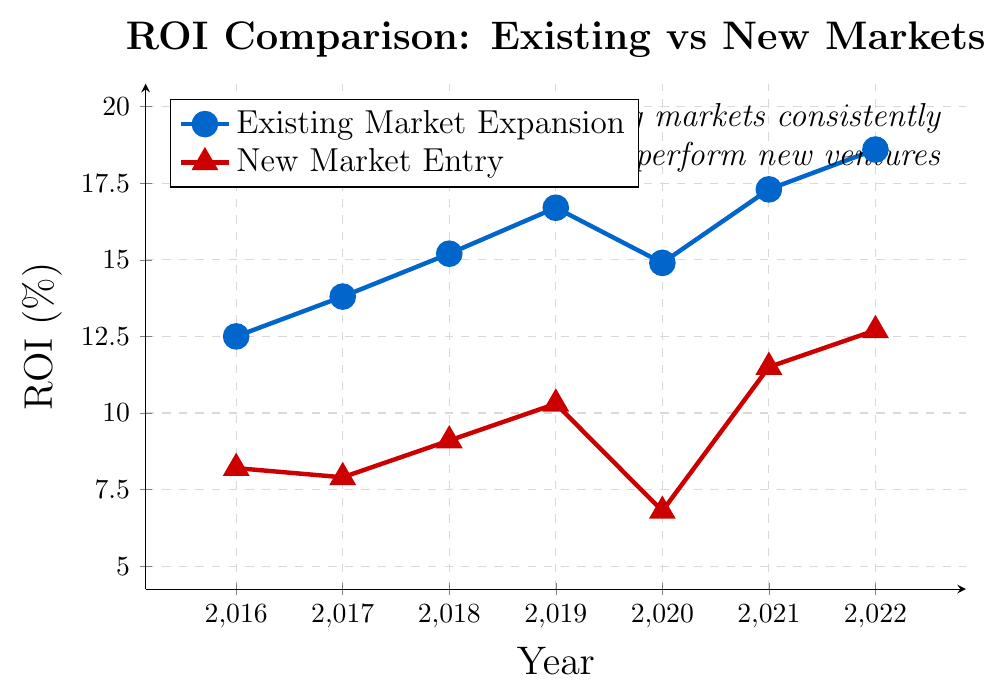What's the total increase in ROI for Existing Market Expansion from 2016 to 2022? To find the total increase, subtract the ROI in 2016 from the ROI in 2022. ROI in 2022 is 18.6% and in 2016 is 12.5%. The increase = 18.6% - 12.5% = 6.1%.
Answer: 6.1% Which year experienced the highest ROI for New Market Entry, and what was the ROI? Identify the highest point on the New Market Entry line (red triangle markers). The highest ROI value is in 2022, which is 12.7%.
Answer: 2022, 12.7% In which year was the gap between the ROIs of Existing Market Expansion and New Market Entry the smallest? Calculate the difference in ROI for each year: 2016: 12.5%-8.2%=4.3%, 2017: 13.8%-7.9%=5.9%, 2018: 15.2%-9.1%=6.1%, 2019: 16.7%-10.3%=6.4%, 2020: 14.9%-6.8%=8.1%, 2021: 17.3%-11.5%=5.8%, 2022: 18.6%-12.7%=5.9%. The smallest gap is in 2016, with 4.3%.
Answer: 2016 What is the average ROI for Existing Market Expansion from 2016 to 2022? List all the ROI values for Existing Market Expansion: 12.5%, 13.8%, 15.2%, 16.7%, 14.9%, 17.3%, 18.6%. Sum them up = 109.0%. Dividing by the number of years (7), the average ROI = 109.0% / 7 ≈ 15.57%.
Answer: 15.57% Did any year experience a decrease in ROI for Existing Market Expansion compared to the previous year? If so, which year? Compare ROI values year over year for Existing Market Expansion: 2016 to 2017 (increase), 2017 to 2018 (increase), 2018 to 2019 (increase), 2019 to 2020 (decrease), 2020 to 2021 (increase), 2021 to 2022 (increase). 2020 had a decrease compared to 2019.
Answer: 2020 What is the combined ROI for both strategies in 2021? Add the ROI values for both strategies in 2021: Existing Market Expansion (17.3%) + New Market Entry (11.5%) = 28.8%.
Answer: 28.8% By how much did the ROI for New Market Entry change from 2019 to 2020? Subtract the ROI in 2019 from the ROI in 2020 for New Market Entry: 2020 ROI (6.8%) - 2019 ROI (10.3%) = -3.5%. This indicates a decrease of 3.5%.
Answer: -3.5% Are there any years in which the ROI for New Market Entry exceeded the ROI for Existing Market Expansion? Visually compare the two lines year by year; the Existing Market Expansion ROI is always higher than the New Market Entry ROI in all the years shown (2016-2022).
Answer: No 